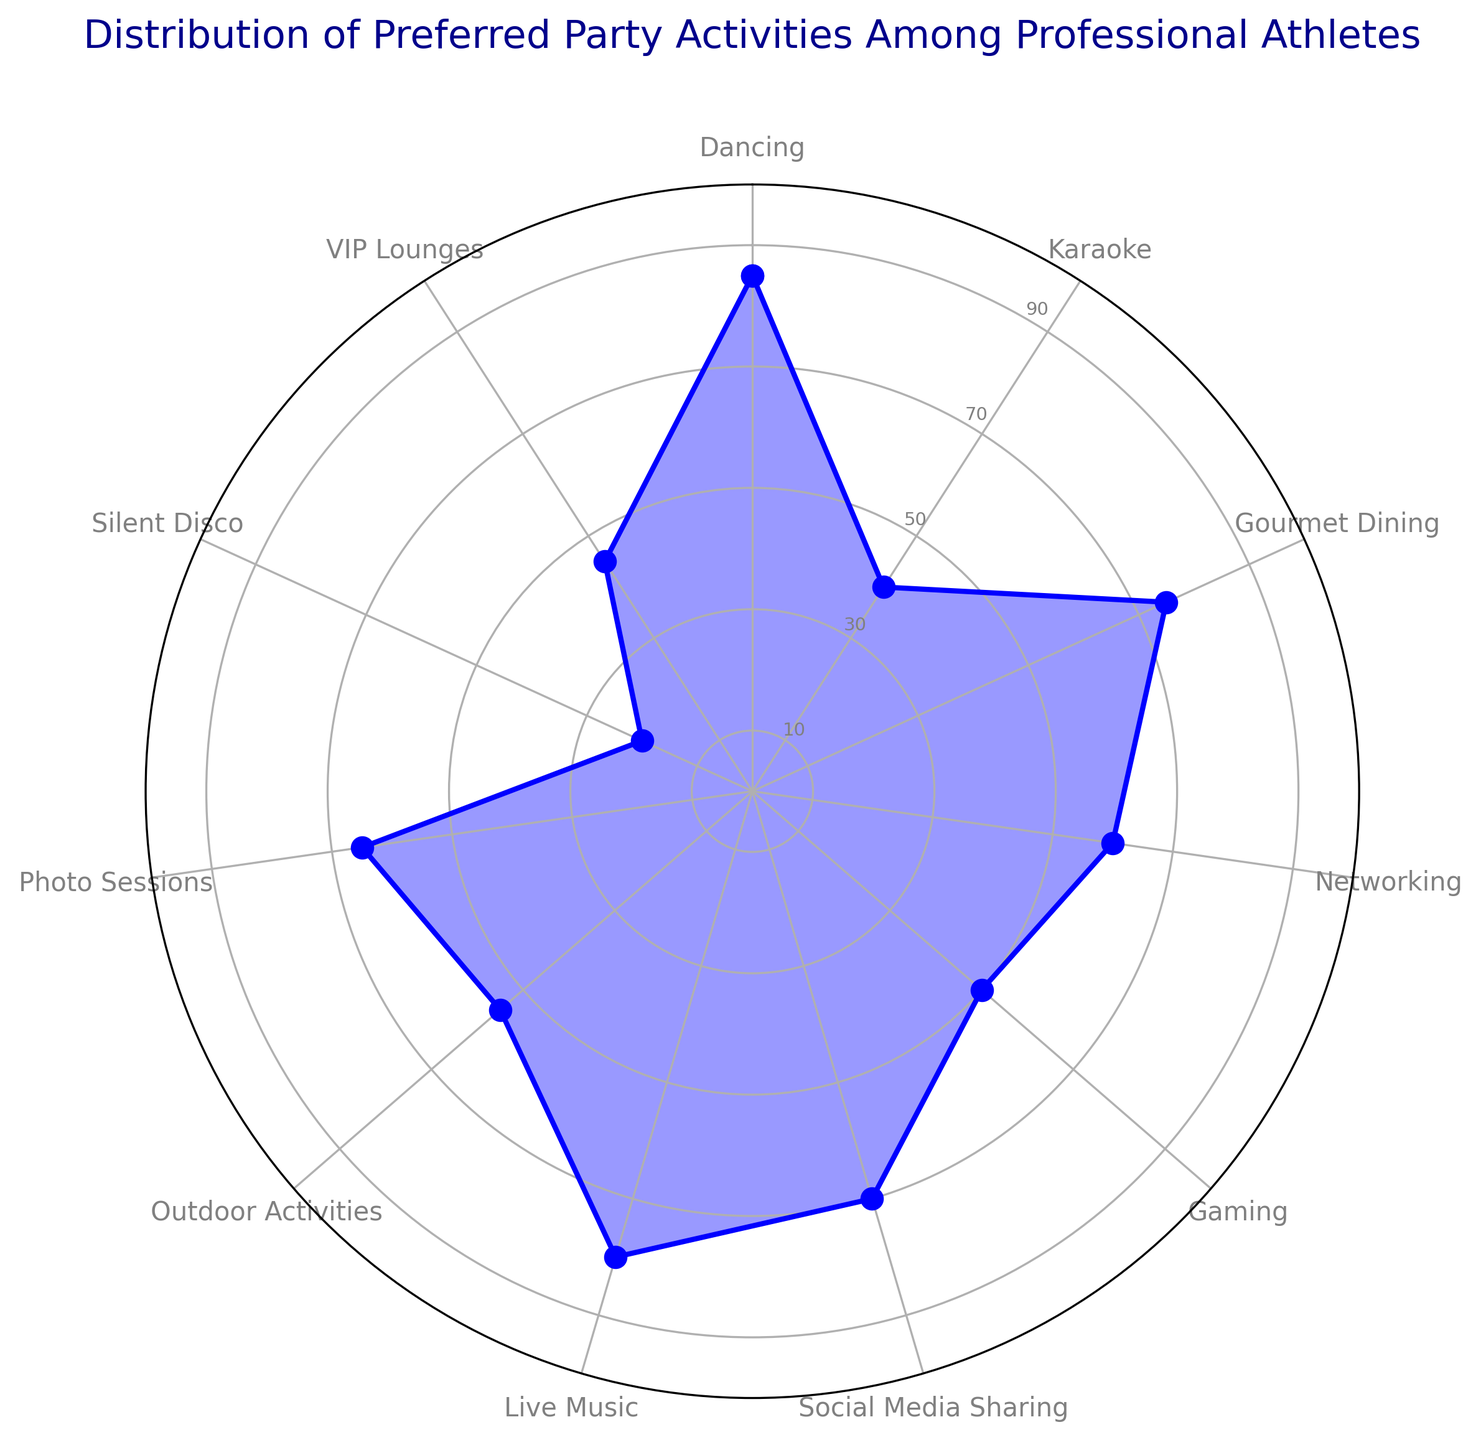Which party activity has the highest preference among professional athletes? The longest bar on the radar chart represents the highest percentage, indicating the activity with the highest preference. The activity 'Dancing' shows the highest point on the radar chart.
Answer: Dancing Which activity is preferred more, Karaoke or Gaming? Compare the heights of the points corresponding to Karaoke and Gaming. Karaoke has a height of 40%, while Gaming has a height of 50%.
Answer: Gaming What is the difference in preference percentage between Outdoor Activities and VIP Lounges? Subtract the percentage of VIP Lounges (45%) from the percentage of Outdoor Activities (55%) using the given data. 55% - 45% = 10%.
Answer: 10% What is the average preference percentage among the activities: Gourmet Dining, Live Music, and Social Media Sharing? Sum the percentages of Gourmet Dining (75%), Live Music (80%), and Social Media Sharing (70%), and divide by 3. (75 + 80 + 70) / 3 = 75%.
Answer: 75% Which activities fall below the 50% preference level? Look for the points on the radar chart that are below the 50% mark. The activities that fall below 50% are Karaoke (40%), Silent Disco (20%), and VIP Lounges (45%).
Answer: Karaoke, Silent Disco, VIP Lounges Are there any activities with equal preference percentages? Check if any of the points on the radar chart are at the same height. There are no overlapping points, so no activities share the same preference percentage.
Answer: No Which activities are preferred more than Social Media Sharing but less than Dancing? Identify activities with percentages between Social Media Sharing (70%) and Dancing (85%). These are Live Music (80%) and Gourmet Dining (75%).
Answer: Live Music, Gourmet Dining How much more popular is Dancing compared to Silent Disco? Subtract the percentage of Silent Disco (20%) from the percentage of Dancing (85%). 85% - 20% = 65%.
Answer: 65% What is the median preference percentage of all activities shown? Arrange all percentages in ascending order and find the middle value. Ordered: 20, 40, 45, 50, 55, 60, 65, 70, 75, 80, 85. The median value is the 6th number in this ordered list, which is 60%.
Answer: 60% What percentage of athletes prefer Karaoke? Look at the point on the radar chart corresponding to Karaoke. The point indicates a percentage of 40%.
Answer: 40% 